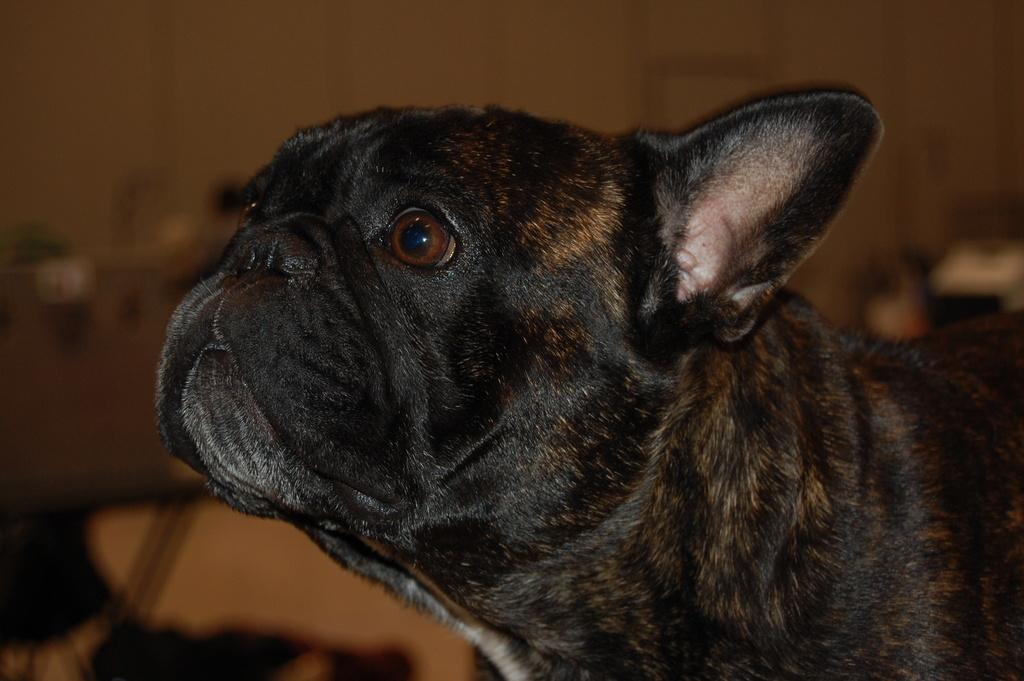What type of animal is present in the image? There is a dog in the image. Can you describe the background of the image? The background of the image is blurry. What type of match is the dog attempting to light in the image? There is no match or any indication of an attempt to light a match in the image. 